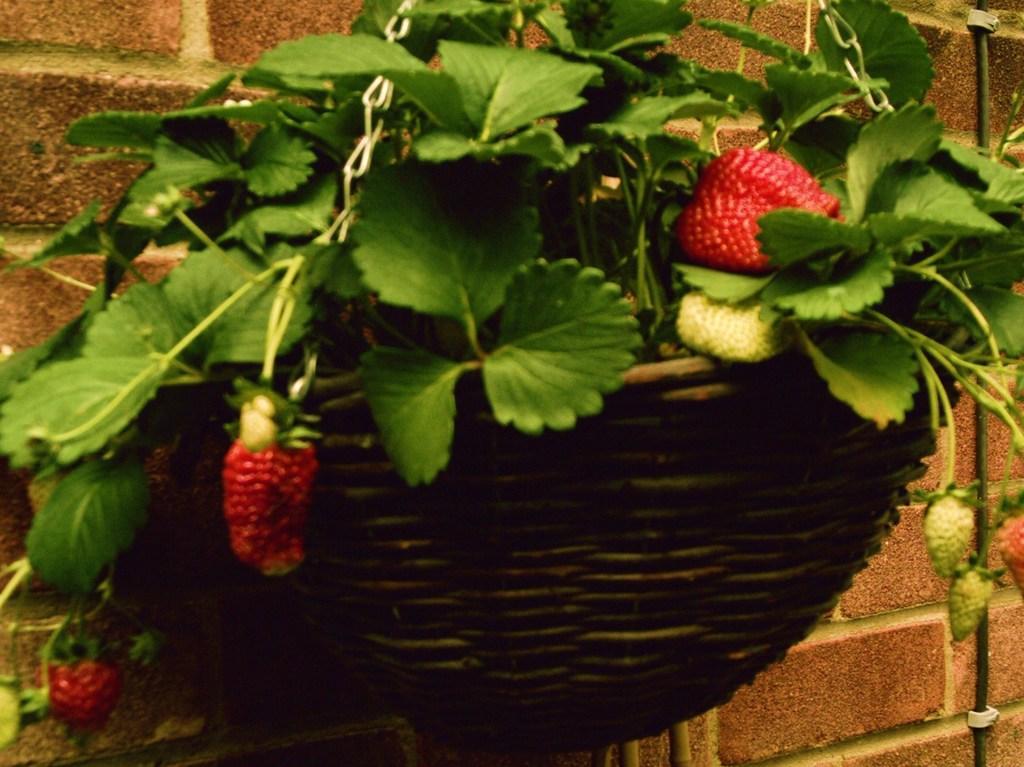Could you give a brief overview of what you see in this image? In this picture I can see there is a flower pot attached to the wall and the flower pot has a plant, there are berries attached to the plant and in the backdrop I can see there is a brick wall. 